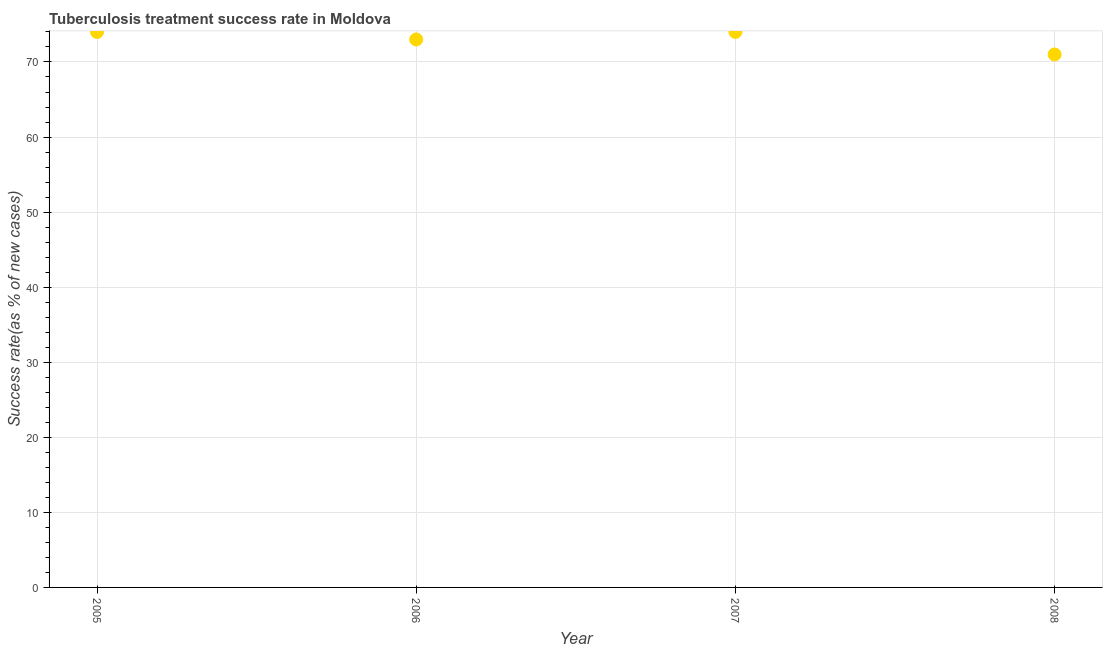What is the tuberculosis treatment success rate in 2007?
Your answer should be very brief. 74. Across all years, what is the maximum tuberculosis treatment success rate?
Provide a short and direct response. 74. Across all years, what is the minimum tuberculosis treatment success rate?
Make the answer very short. 71. In which year was the tuberculosis treatment success rate maximum?
Your answer should be compact. 2005. In which year was the tuberculosis treatment success rate minimum?
Your answer should be compact. 2008. What is the sum of the tuberculosis treatment success rate?
Keep it short and to the point. 292. What is the difference between the tuberculosis treatment success rate in 2005 and 2006?
Provide a short and direct response. 1. What is the median tuberculosis treatment success rate?
Your answer should be very brief. 73.5. In how many years, is the tuberculosis treatment success rate greater than 30 %?
Ensure brevity in your answer.  4. What is the ratio of the tuberculosis treatment success rate in 2005 to that in 2007?
Your response must be concise. 1. Is the difference between the tuberculosis treatment success rate in 2005 and 2007 greater than the difference between any two years?
Ensure brevity in your answer.  No. What is the difference between the highest and the lowest tuberculosis treatment success rate?
Make the answer very short. 3. Does the tuberculosis treatment success rate monotonically increase over the years?
Make the answer very short. No. What is the difference between two consecutive major ticks on the Y-axis?
Provide a succinct answer. 10. Are the values on the major ticks of Y-axis written in scientific E-notation?
Provide a succinct answer. No. Does the graph contain any zero values?
Your answer should be very brief. No. Does the graph contain grids?
Provide a succinct answer. Yes. What is the title of the graph?
Offer a very short reply. Tuberculosis treatment success rate in Moldova. What is the label or title of the Y-axis?
Your answer should be very brief. Success rate(as % of new cases). What is the Success rate(as % of new cases) in 2005?
Your response must be concise. 74. What is the Success rate(as % of new cases) in 2006?
Your answer should be very brief. 73. What is the Success rate(as % of new cases) in 2008?
Give a very brief answer. 71. What is the difference between the Success rate(as % of new cases) in 2005 and 2008?
Make the answer very short. 3. What is the difference between the Success rate(as % of new cases) in 2006 and 2008?
Offer a terse response. 2. What is the ratio of the Success rate(as % of new cases) in 2005 to that in 2006?
Ensure brevity in your answer.  1.01. What is the ratio of the Success rate(as % of new cases) in 2005 to that in 2008?
Make the answer very short. 1.04. What is the ratio of the Success rate(as % of new cases) in 2006 to that in 2007?
Provide a short and direct response. 0.99. What is the ratio of the Success rate(as % of new cases) in 2006 to that in 2008?
Give a very brief answer. 1.03. What is the ratio of the Success rate(as % of new cases) in 2007 to that in 2008?
Your answer should be compact. 1.04. 